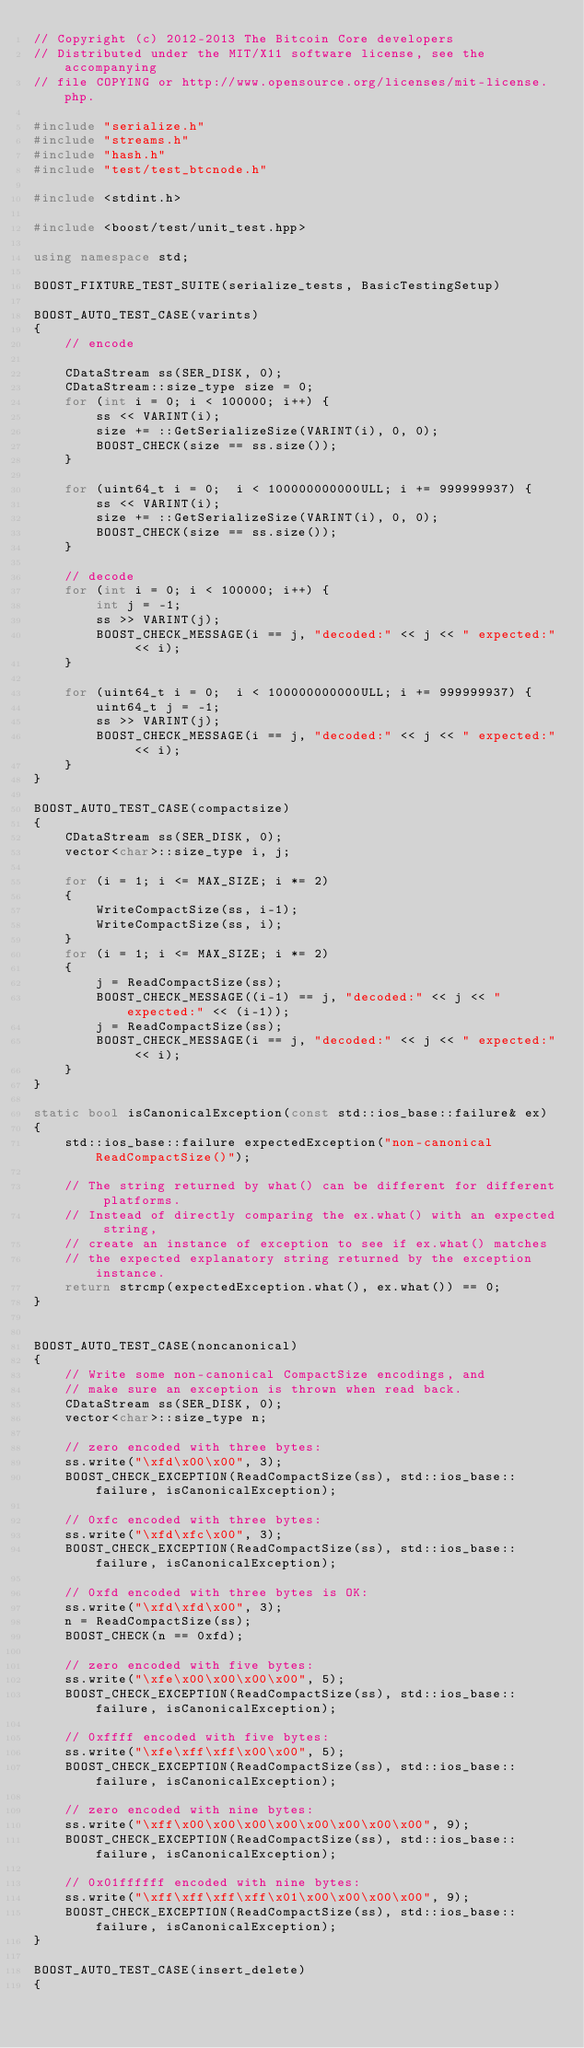<code> <loc_0><loc_0><loc_500><loc_500><_C++_>// Copyright (c) 2012-2013 The Bitcoin Core developers
// Distributed under the MIT/X11 software license, see the accompanying
// file COPYING or http://www.opensource.org/licenses/mit-license.php.

#include "serialize.h"
#include "streams.h"
#include "hash.h"
#include "test/test_btcnode.h"

#include <stdint.h>

#include <boost/test/unit_test.hpp>

using namespace std;

BOOST_FIXTURE_TEST_SUITE(serialize_tests, BasicTestingSetup)

BOOST_AUTO_TEST_CASE(varints)
{
    // encode

    CDataStream ss(SER_DISK, 0);
    CDataStream::size_type size = 0;
    for (int i = 0; i < 100000; i++) {
        ss << VARINT(i);
        size += ::GetSerializeSize(VARINT(i), 0, 0);
        BOOST_CHECK(size == ss.size());
    }

    for (uint64_t i = 0;  i < 100000000000ULL; i += 999999937) {
        ss << VARINT(i);
        size += ::GetSerializeSize(VARINT(i), 0, 0);
        BOOST_CHECK(size == ss.size());
    }

    // decode
    for (int i = 0; i < 100000; i++) {
        int j = -1;
        ss >> VARINT(j);
        BOOST_CHECK_MESSAGE(i == j, "decoded:" << j << " expected:" << i);
    }

    for (uint64_t i = 0;  i < 100000000000ULL; i += 999999937) {
        uint64_t j = -1;
        ss >> VARINT(j);
        BOOST_CHECK_MESSAGE(i == j, "decoded:" << j << " expected:" << i);
    }
}

BOOST_AUTO_TEST_CASE(compactsize)
{
    CDataStream ss(SER_DISK, 0);
    vector<char>::size_type i, j;

    for (i = 1; i <= MAX_SIZE; i *= 2)
    {
        WriteCompactSize(ss, i-1);
        WriteCompactSize(ss, i);
    }
    for (i = 1; i <= MAX_SIZE; i *= 2)
    {
        j = ReadCompactSize(ss);
        BOOST_CHECK_MESSAGE((i-1) == j, "decoded:" << j << " expected:" << (i-1));
        j = ReadCompactSize(ss);
        BOOST_CHECK_MESSAGE(i == j, "decoded:" << j << " expected:" << i);
    }
}

static bool isCanonicalException(const std::ios_base::failure& ex)
{
    std::ios_base::failure expectedException("non-canonical ReadCompactSize()");

    // The string returned by what() can be different for different platforms.
    // Instead of directly comparing the ex.what() with an expected string,
    // create an instance of exception to see if ex.what() matches
    // the expected explanatory string returned by the exception instance.
    return strcmp(expectedException.what(), ex.what()) == 0;
}


BOOST_AUTO_TEST_CASE(noncanonical)
{
    // Write some non-canonical CompactSize encodings, and
    // make sure an exception is thrown when read back.
    CDataStream ss(SER_DISK, 0);
    vector<char>::size_type n;

    // zero encoded with three bytes:
    ss.write("\xfd\x00\x00", 3);
    BOOST_CHECK_EXCEPTION(ReadCompactSize(ss), std::ios_base::failure, isCanonicalException);

    // 0xfc encoded with three bytes:
    ss.write("\xfd\xfc\x00", 3);
    BOOST_CHECK_EXCEPTION(ReadCompactSize(ss), std::ios_base::failure, isCanonicalException);

    // 0xfd encoded with three bytes is OK:
    ss.write("\xfd\xfd\x00", 3);
    n = ReadCompactSize(ss);
    BOOST_CHECK(n == 0xfd);

    // zero encoded with five bytes:
    ss.write("\xfe\x00\x00\x00\x00", 5);
    BOOST_CHECK_EXCEPTION(ReadCompactSize(ss), std::ios_base::failure, isCanonicalException);

    // 0xffff encoded with five bytes:
    ss.write("\xfe\xff\xff\x00\x00", 5);
    BOOST_CHECK_EXCEPTION(ReadCompactSize(ss), std::ios_base::failure, isCanonicalException);

    // zero encoded with nine bytes:
    ss.write("\xff\x00\x00\x00\x00\x00\x00\x00\x00", 9);
    BOOST_CHECK_EXCEPTION(ReadCompactSize(ss), std::ios_base::failure, isCanonicalException);

    // 0x01ffffff encoded with nine bytes:
    ss.write("\xff\xff\xff\xff\x01\x00\x00\x00\x00", 9);
    BOOST_CHECK_EXCEPTION(ReadCompactSize(ss), std::ios_base::failure, isCanonicalException);
}

BOOST_AUTO_TEST_CASE(insert_delete)
{</code> 